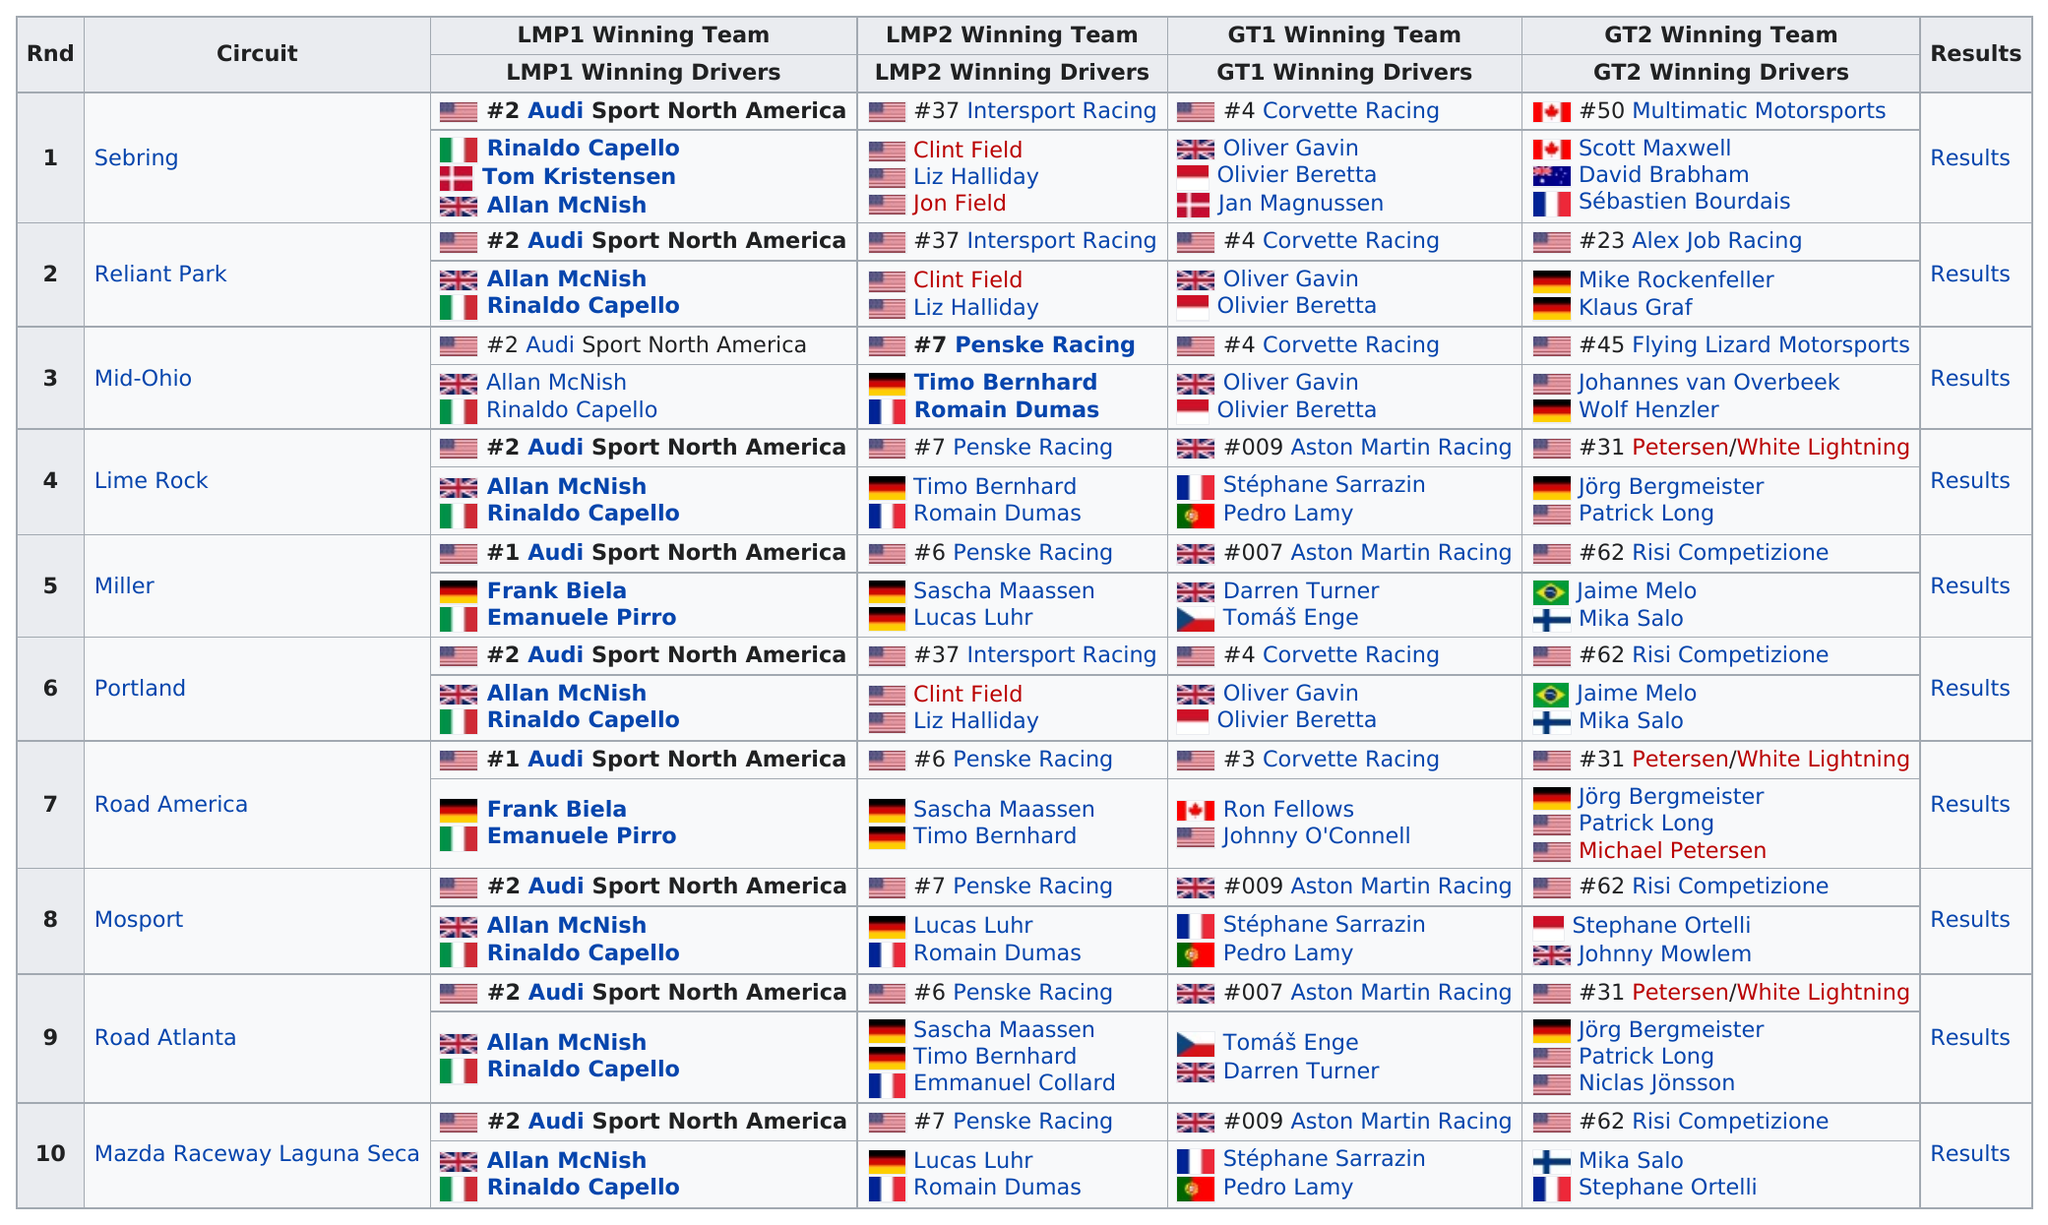Point out several critical features in this image. Clint Field, Liz Halliday, and Jon Field are three American racers who won their races consecutively in the order they competed. The total number of circuits listed on the chart is 10. In round 2, the driver listed last under LMP1 winning drivers is Rinaldo Capello. 5 countries participated in the Reliant Park event. There were a total of 10 races. 